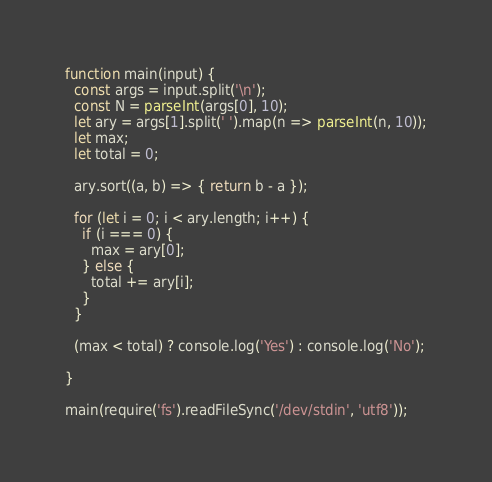Convert code to text. <code><loc_0><loc_0><loc_500><loc_500><_JavaScript_>function main(input) {
  const args = input.split('\n');
  const N = parseInt(args[0], 10);
  let ary = args[1].split(' ').map(n => parseInt(n, 10));
  let max;
  let total = 0;
  
  ary.sort((a, b) => { return b - a });
  
  for (let i = 0; i < ary.length; i++) {
    if (i === 0) { 
      max = ary[0];
    } else {
      total += ary[i];
    }
  }
  
  (max < total) ? console.log('Yes') : console.log('No');
  
}

main(require('fs').readFileSync('/dev/stdin', 'utf8'));
</code> 